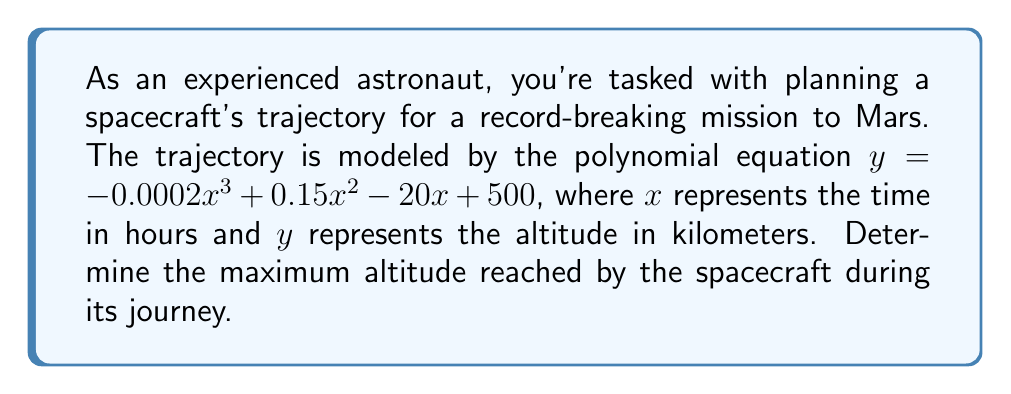Can you solve this math problem? To find the maximum altitude, we need to follow these steps:

1) The maximum point of a polynomial function occurs where its derivative equals zero. Let's find the derivative of the given function:

   $f(x) = -0.0002x^3 + 0.15x^2 - 20x + 500$
   $f'(x) = -0.0006x^2 + 0.3x - 20$

2) Set the derivative equal to zero and solve for x:

   $-0.0006x^2 + 0.3x - 20 = 0$

3) This is a quadratic equation. We can solve it using the quadratic formula:
   $x = \frac{-b \pm \sqrt{b^2 - 4ac}}{2a}$

   Where $a = -0.0006$, $b = 0.3$, and $c = -20$

4) Plugging these values into the quadratic formula:

   $x = \frac{-0.3 \pm \sqrt{0.3^2 - 4(-0.0006)(-20)}}{2(-0.0006)}$

5) Simplifying:

   $x = \frac{-0.3 \pm \sqrt{0.09 + 0.048}}{-0.0012}$
   $x = \frac{-0.3 \pm \sqrt{0.138}}{-0.0012}$
   $x = \frac{-0.3 \pm 0.371}{-0.0012}$

6) This gives us two solutions:

   $x_1 = \frac{-0.3 + 0.371}{-0.0012} = -59.17$
   $x_2 = \frac{-0.3 - 0.371}{-0.0012} = 559.17$

7) Since time cannot be negative in this context, we use $x = 559.17$ hours.

8) To find the maximum altitude, we plug this x-value back into the original function:

   $y = -0.0002(559.17)^3 + 0.15(559.17)^2 - 20(559.17) + 500$

9) Calculating this gives us:

   $y \approx 17,141.7$ km

Therefore, the maximum altitude reached by the spacecraft is approximately 17,141.7 km.
Answer: 17,141.7 km 